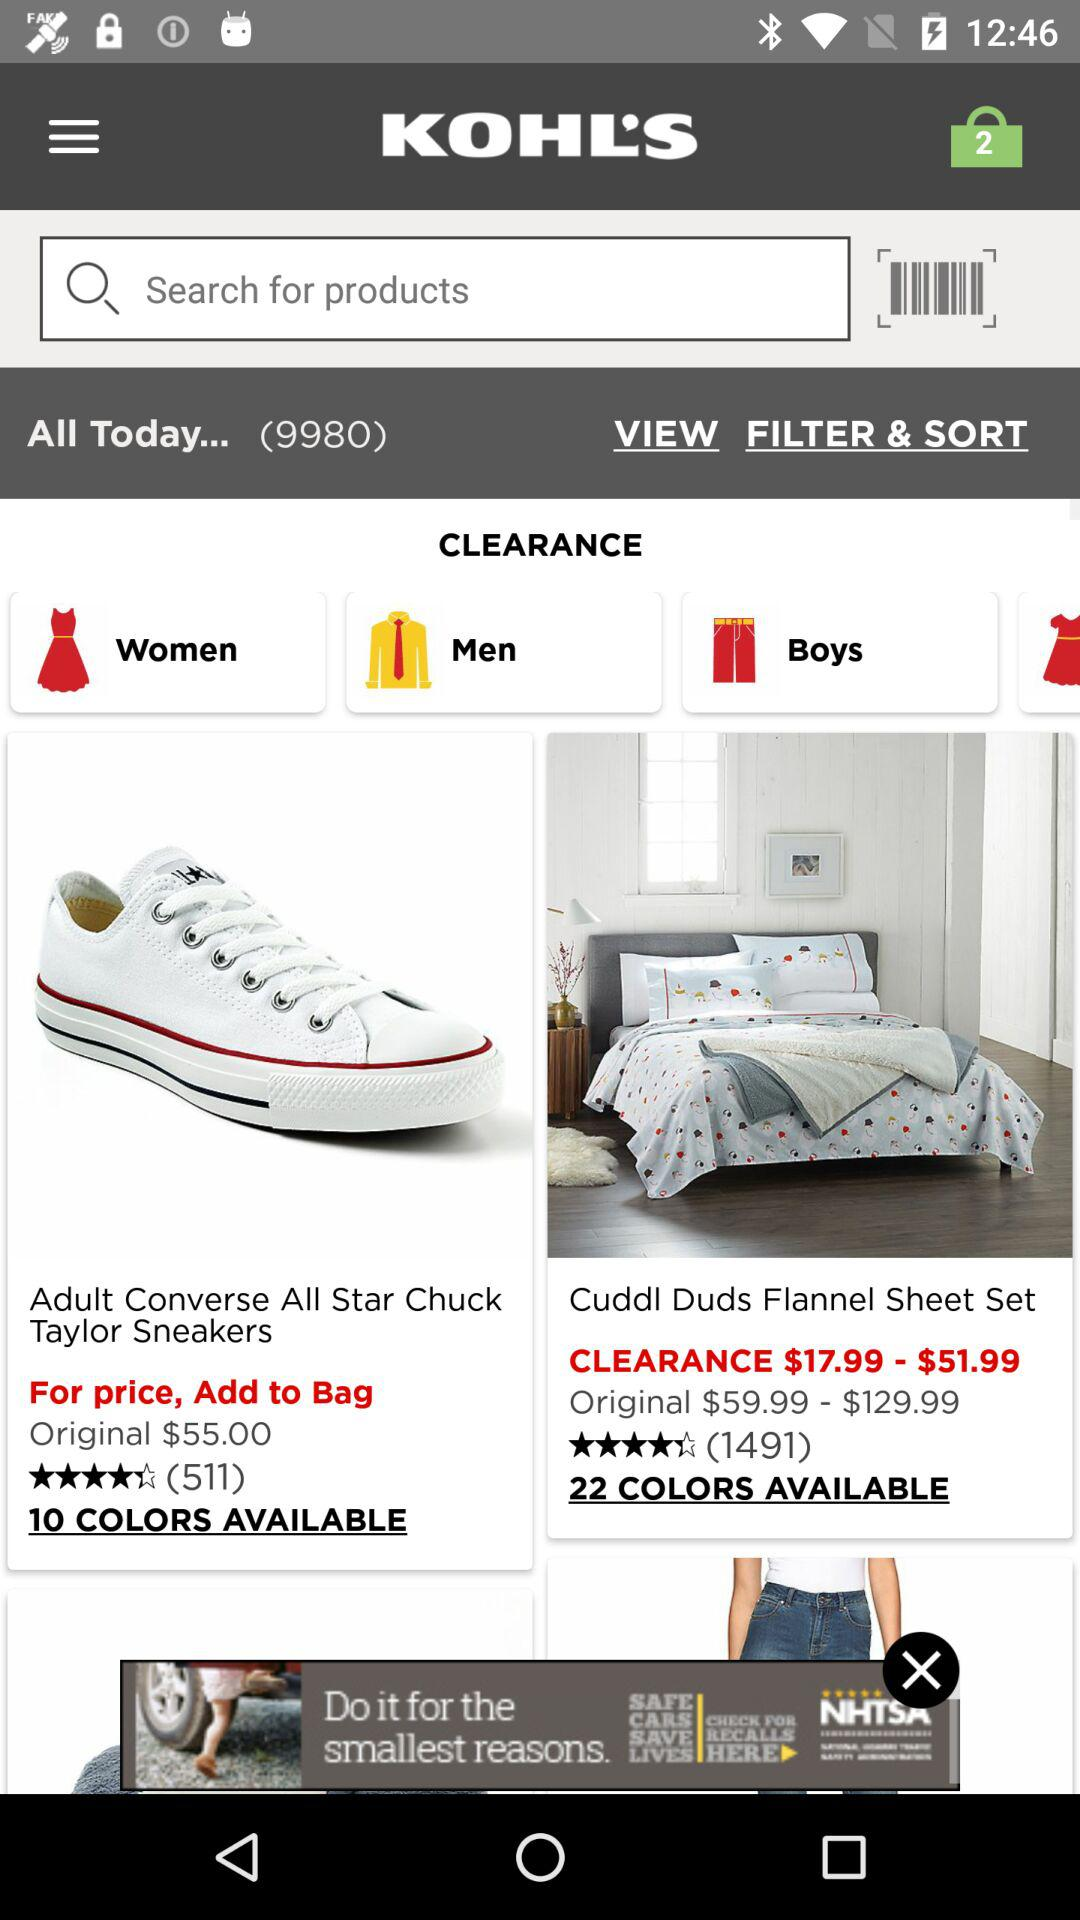What is the rating of sneakers? The rating of sneakers is 4.2 stars. 